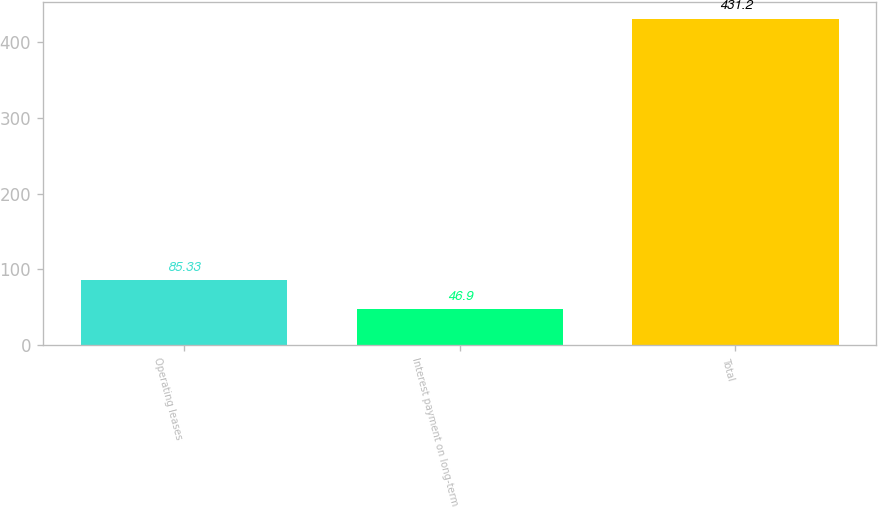Convert chart to OTSL. <chart><loc_0><loc_0><loc_500><loc_500><bar_chart><fcel>Operating leases<fcel>Interest payment on long-term<fcel>Total<nl><fcel>85.33<fcel>46.9<fcel>431.2<nl></chart> 